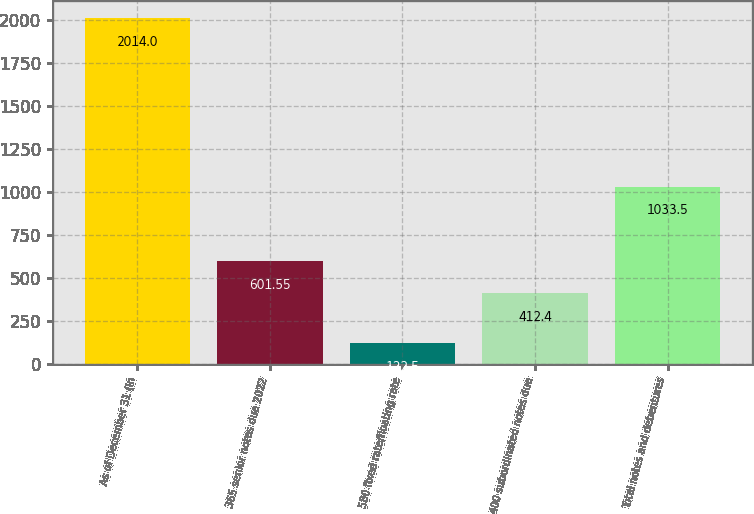Convert chart to OTSL. <chart><loc_0><loc_0><loc_500><loc_500><bar_chart><fcel>As of December 31 (in<fcel>365 senior notes due 2022<fcel>580 fixed rate/floating rate<fcel>400 subordinated notes due<fcel>Total notes and debentures<nl><fcel>2014<fcel>601.55<fcel>122.5<fcel>412.4<fcel>1033.5<nl></chart> 